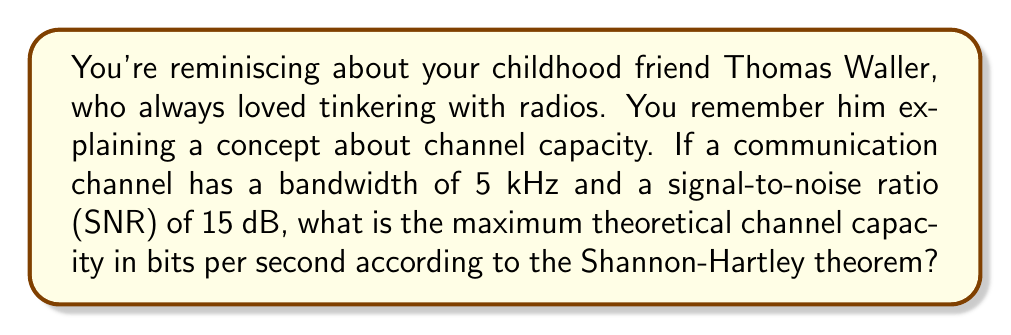Can you solve this math problem? To solve this problem, we'll use the Shannon-Hartley theorem, which gives the channel capacity for a noisy communication channel. The theorem is expressed as:

$$C = B \log_2(1 + SNR)$$

Where:
$C$ = Channel capacity in bits per second (bps)
$B$ = Bandwidth in Hertz (Hz)
$SNR$ = Signal-to-Noise Ratio (linear, not dB)

Given:
- Bandwidth ($B$) = 5 kHz = 5000 Hz
- SNR = 15 dB

Step 1: Convert SNR from dB to linear scale
SNR in linear scale = $10^{(SNR_{dB}/10)}$
$SNR_{linear} = 10^{(15/10)} = 10^{1.5} \approx 31.6228$

Step 2: Apply the Shannon-Hartley theorem
$$\begin{align}
C &= B \log_2(1 + SNR) \\
&= 5000 \cdot \log_2(1 + 31.6228) \\
&= 5000 \cdot \log_2(32.6228) \\
&= 5000 \cdot 5.0279 \\
&= 25,139.5 \text{ bps}
\end{align}$$

Step 3: Round to the nearest whole number
Channel Capacity ≈ 25,140 bps
Answer: The maximum theoretical channel capacity is approximately 25,140 bits per second. 